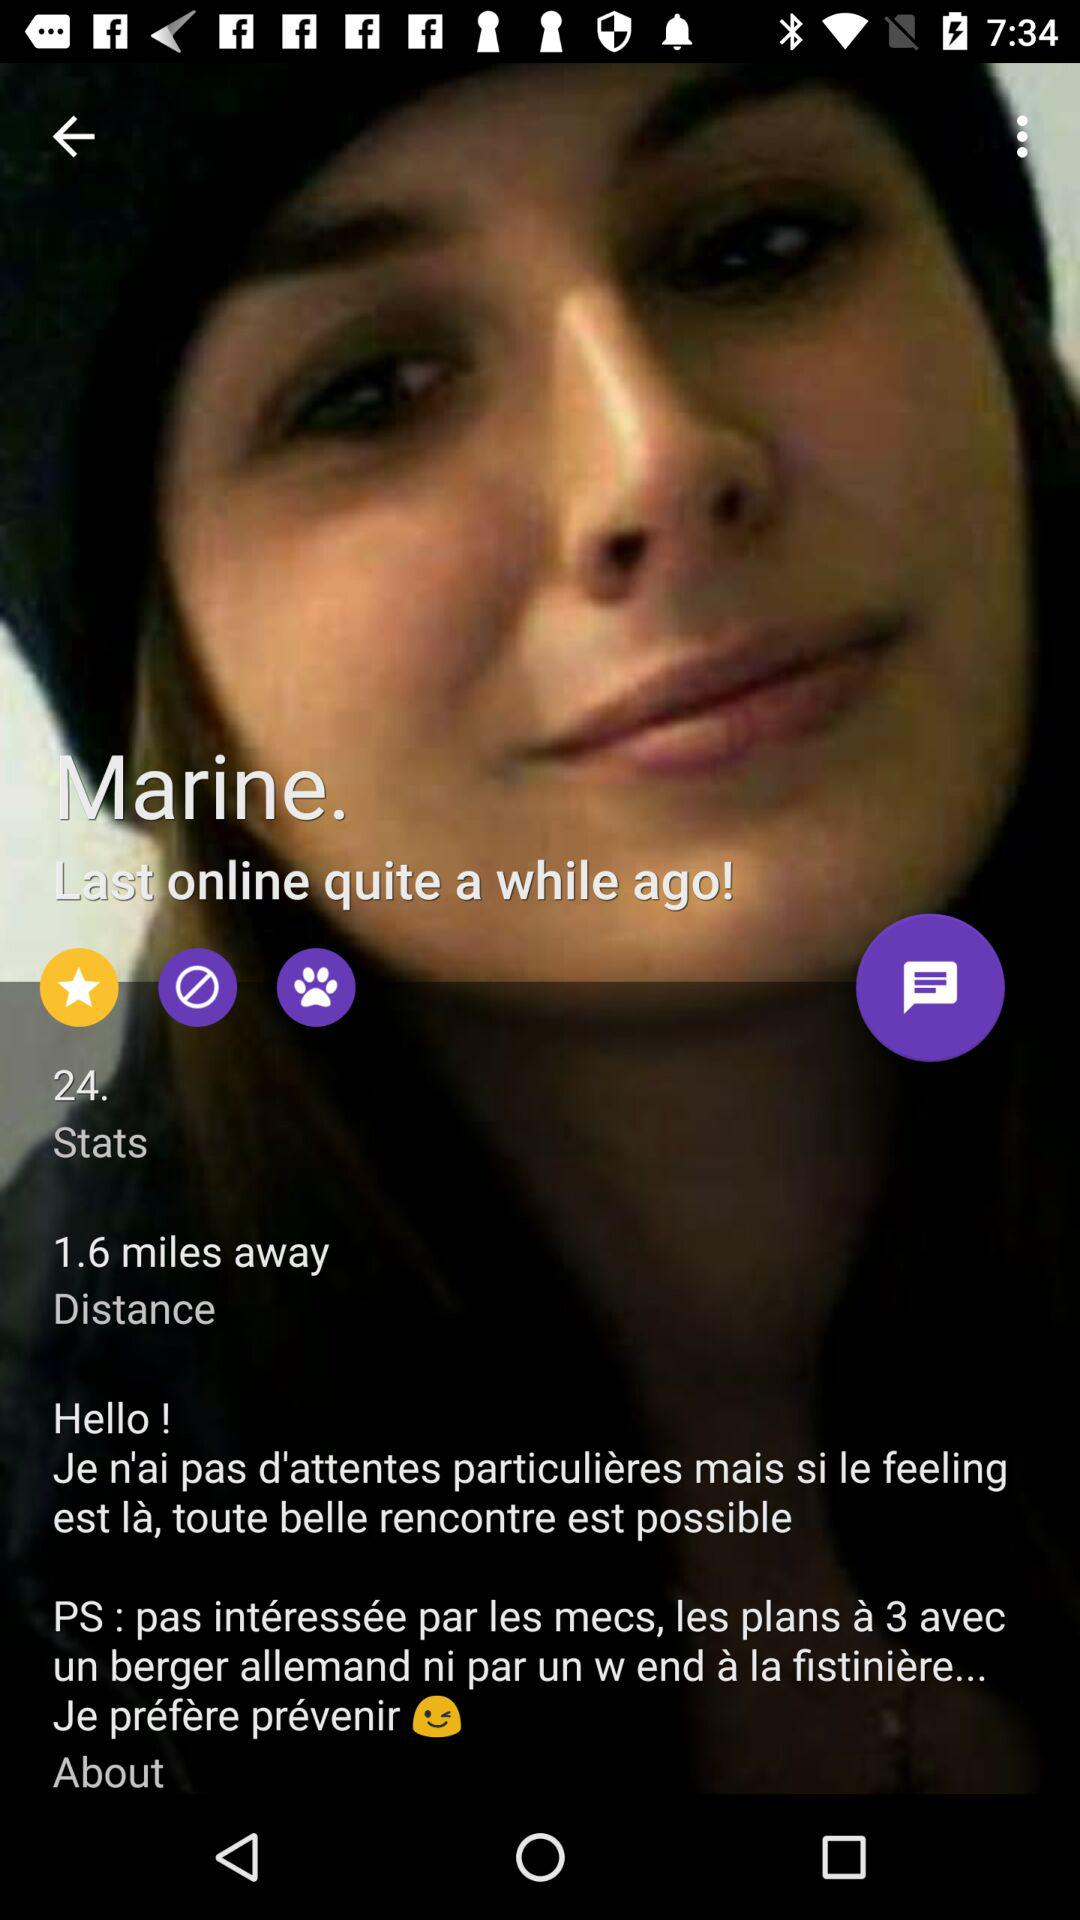Where does "Marine" live?
When the provided information is insufficient, respond with <no answer>. <no answer> 